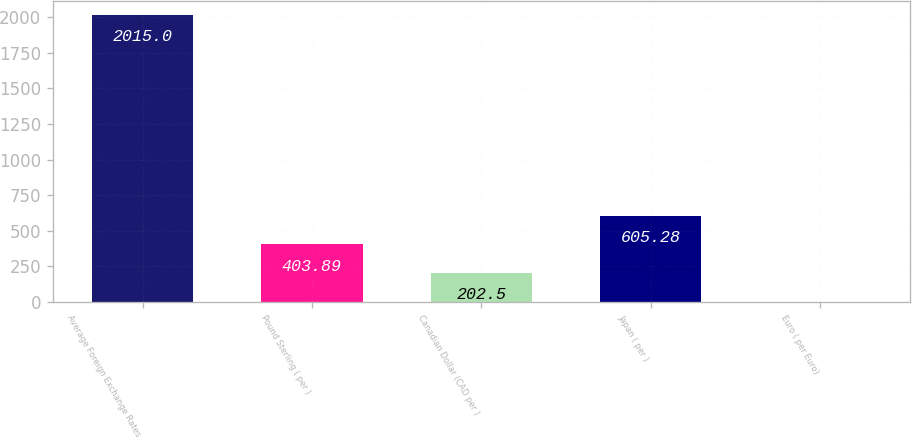<chart> <loc_0><loc_0><loc_500><loc_500><bar_chart><fcel>Average Foreign Exchange Rates<fcel>Pound Sterling ( per )<fcel>Canadian Dollar (CAD per )<fcel>Japan ( per )<fcel>Euro ( per Euro)<nl><fcel>2015<fcel>403.89<fcel>202.5<fcel>605.28<fcel>1.11<nl></chart> 